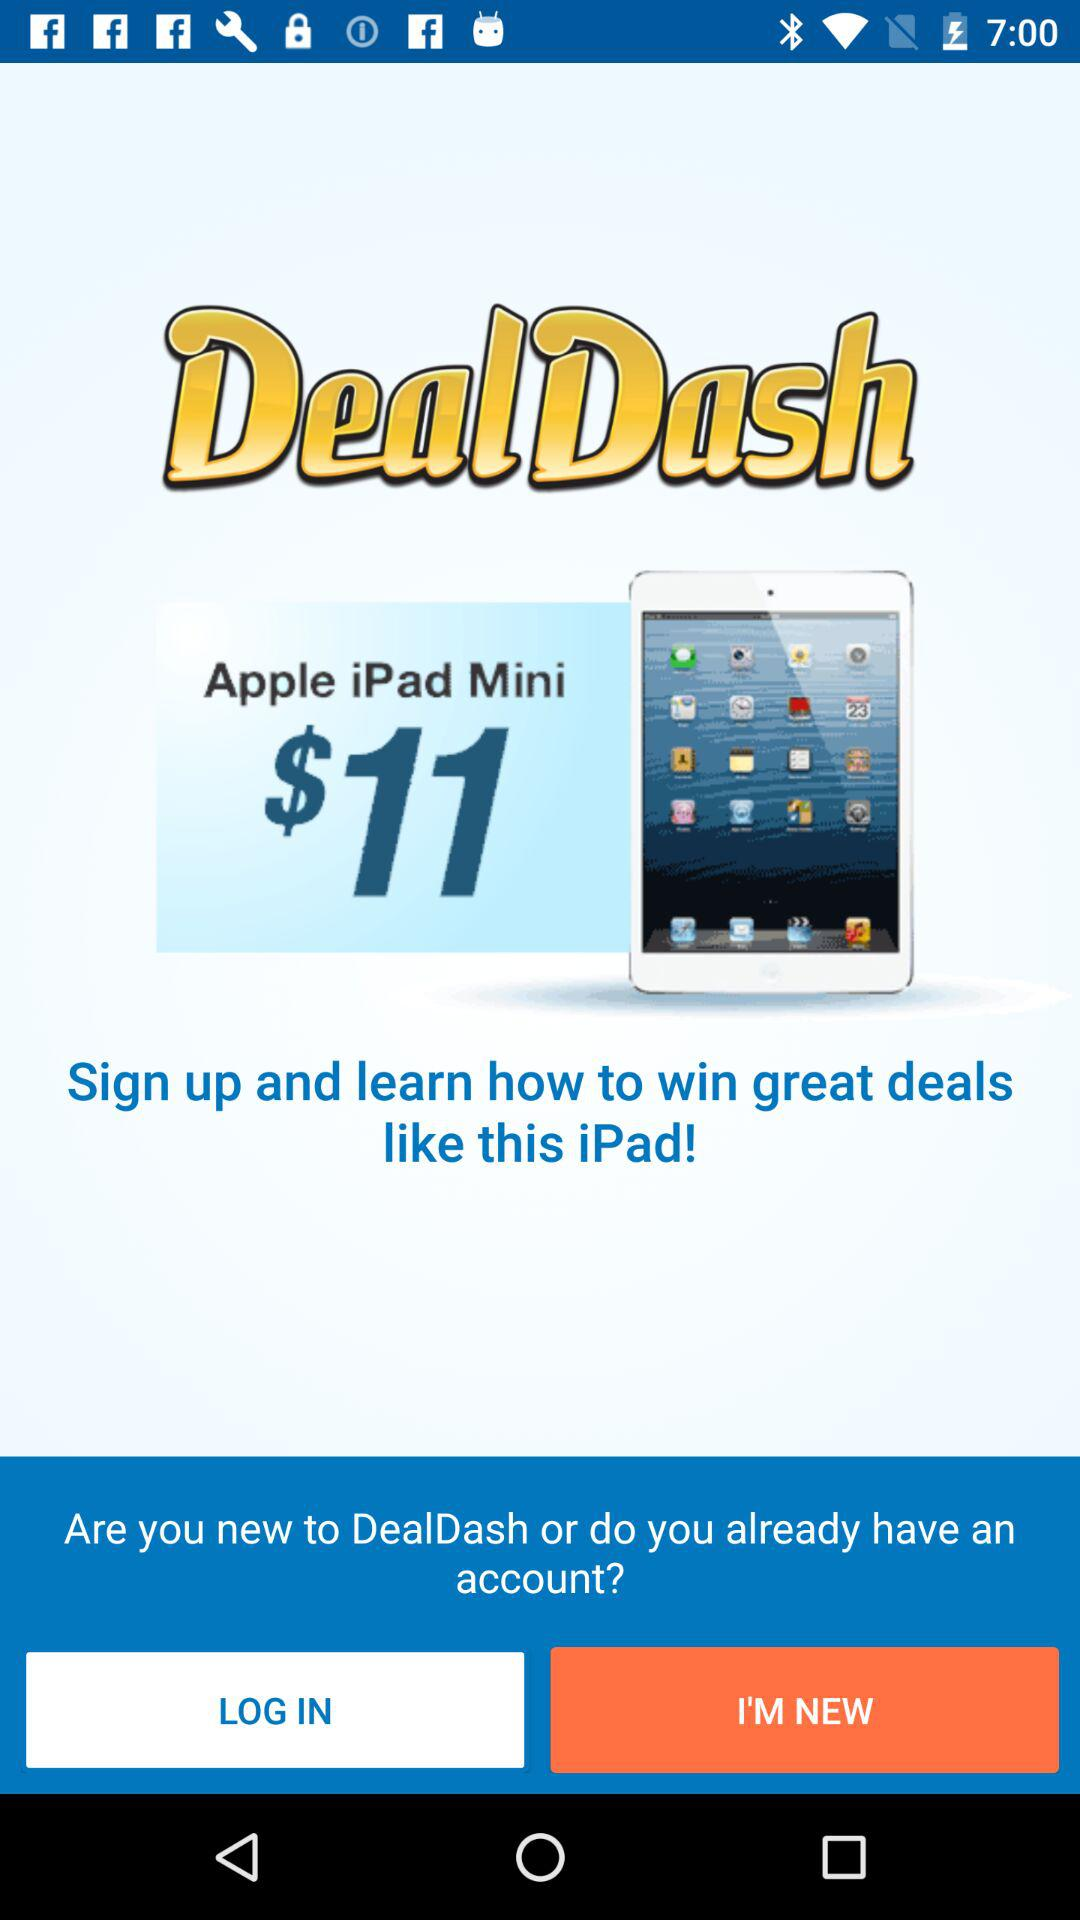How much is the iPad Mini?
Answer the question using a single word or phrase. $11 